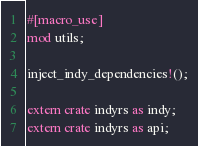<code> <loc_0><loc_0><loc_500><loc_500><_Rust_>#[macro_use]
mod utils;

inject_indy_dependencies!();

extern crate indyrs as indy;
extern crate indyrs as api;</code> 